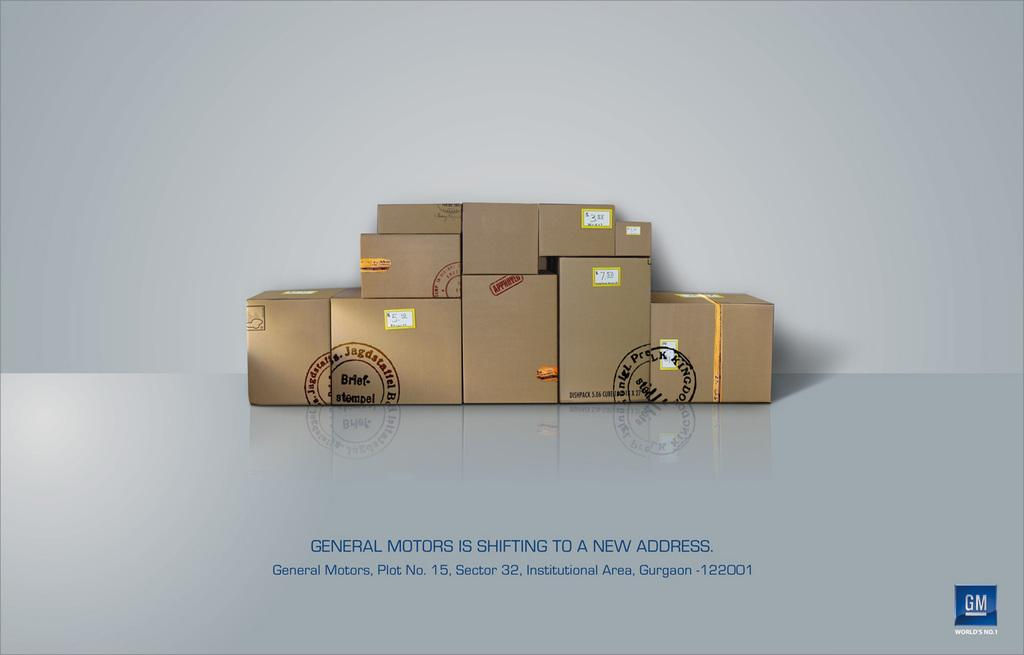<image>
Share a concise interpretation of the image provided. Sign that says general motors is shifting to a new address. 